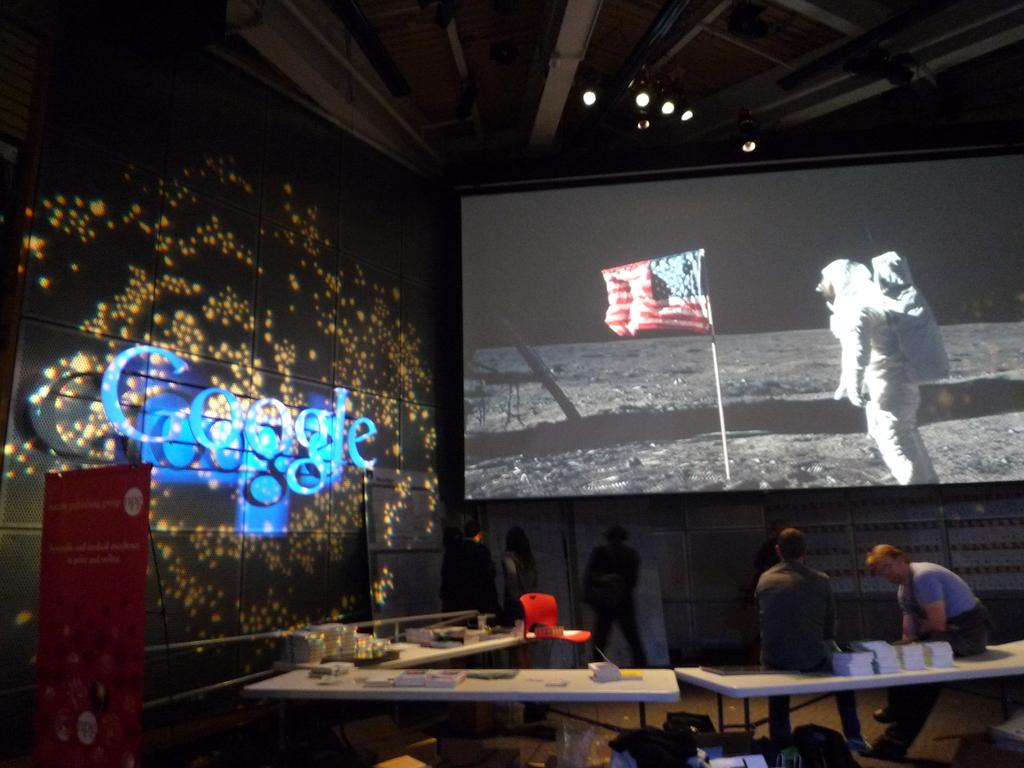What is the main object in the image? There is a screen in the image. What are the people near the screen doing? There are people standing near the screen. What are the two men doing in the image? Two men are sitting on a table. What can be found on the table? There are items on the table. What is on the left side of the image? There is a hoarding on the left side of the image. What type of bean is being discussed by the people near the screen? There is no bean present in the image, nor is there any discussion about beans. 